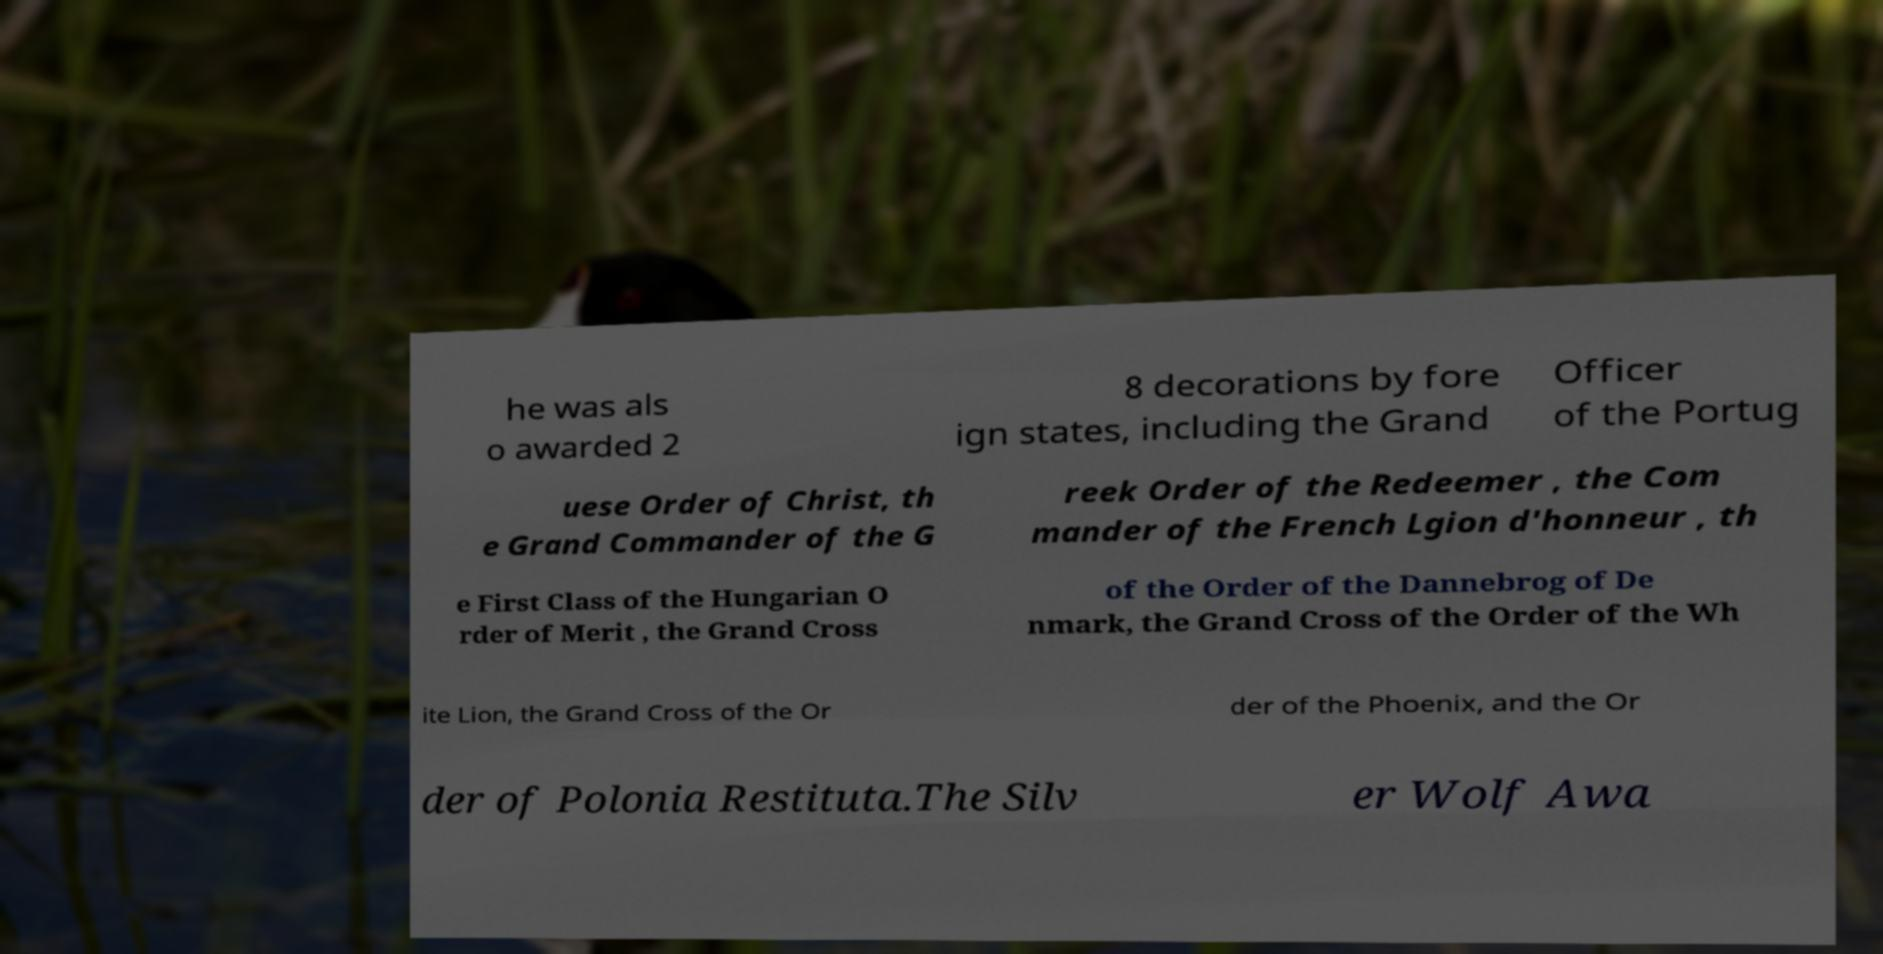What messages or text are displayed in this image? I need them in a readable, typed format. he was als o awarded 2 8 decorations by fore ign states, including the Grand Officer of the Portug uese Order of Christ, th e Grand Commander of the G reek Order of the Redeemer , the Com mander of the French Lgion d'honneur , th e First Class of the Hungarian O rder of Merit , the Grand Cross of the Order of the Dannebrog of De nmark, the Grand Cross of the Order of the Wh ite Lion, the Grand Cross of the Or der of the Phoenix, and the Or der of Polonia Restituta.The Silv er Wolf Awa 